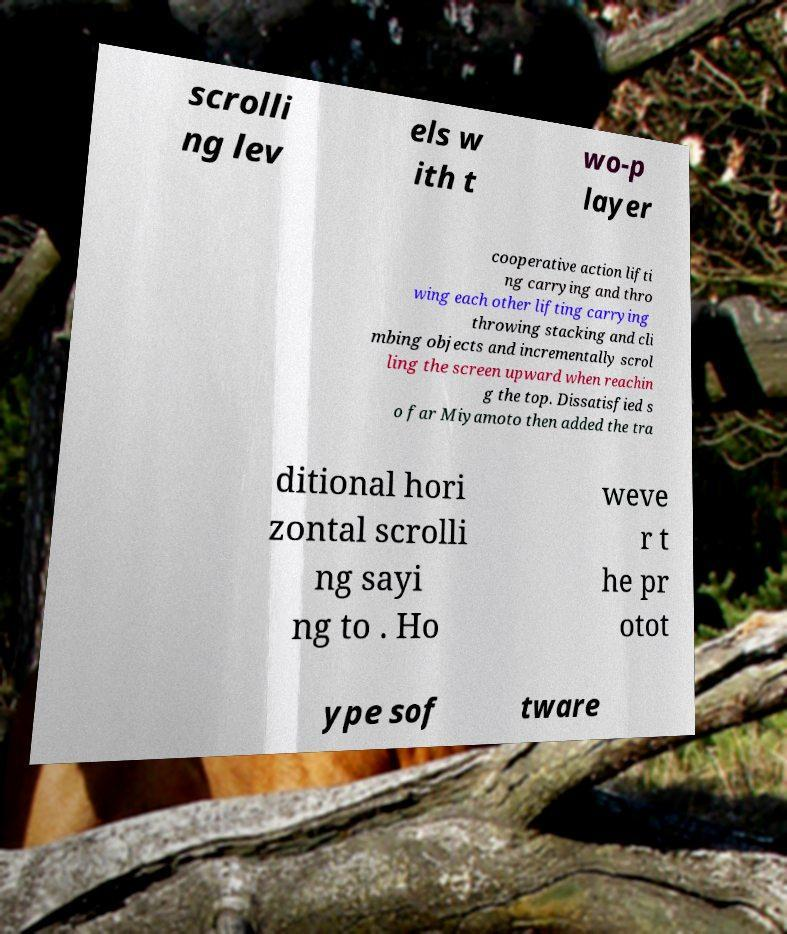Could you assist in decoding the text presented in this image and type it out clearly? scrolli ng lev els w ith t wo-p layer cooperative action lifti ng carrying and thro wing each other lifting carrying throwing stacking and cli mbing objects and incrementally scrol ling the screen upward when reachin g the top. Dissatisfied s o far Miyamoto then added the tra ditional hori zontal scrolli ng sayi ng to . Ho weve r t he pr otot ype sof tware 